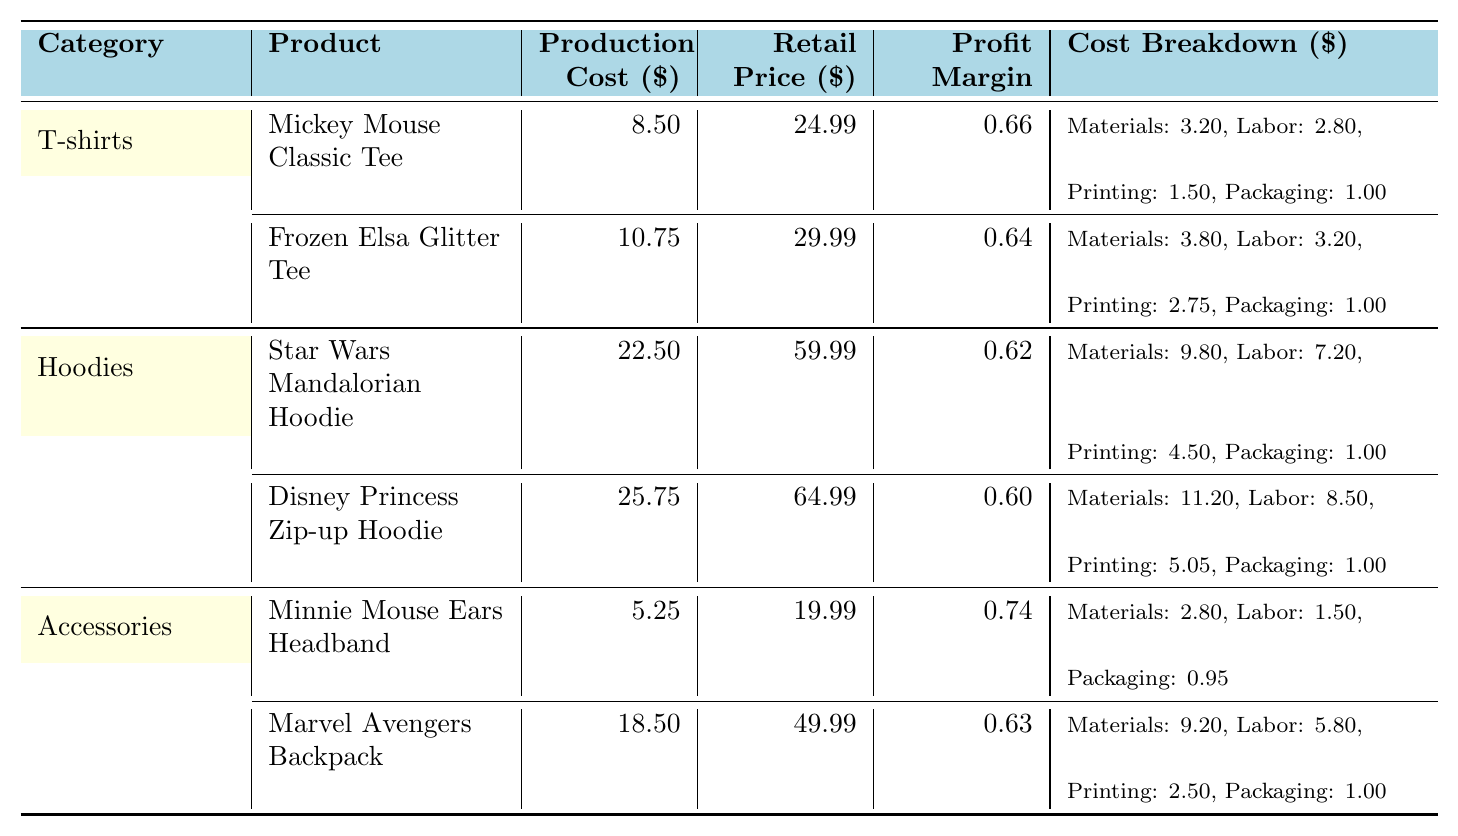What is the profit margin of the Mickey Mouse Classic Tee? The profit margin for the Mickey Mouse Classic Tee is listed in the table under the Profit Margin column, which shows a value of 0.66.
Answer: 0.66 What is the production cost of the Frozen Elsa Glitter Tee? The production cost of the Frozen Elsa Glitter Tee can be found under the Production Cost column, which indicates a value of 10.75.
Answer: 10.75 Which product has the highest profit margin? By comparing the profit margins in the Profit Margin column, the Minnie Mouse Ears Headband has a profit margin of 0.74, which is higher than the others.
Answer: Minnie Mouse Ears Headband What is the total production cost for all T-shirts? The production costs for T-shirts are 8.50 (Mickey Mouse Classic Tee) and 10.75 (Frozen Elsa Glitter Tee). The total is calculated as 8.50 + 10.75 = 19.25.
Answer: 19.25 Which category has the highest retail price for a product? By examining the Retail Price column, the Disney Princess Zip-up Hoodie has the highest retail price of 64.99.
Answer: Hoodies What is the average profit margin across all categories? The profit margins are 0.66, 0.64, 0.62, 0.60, 0.74, and 0.63. Summing these gives 3.19, and dividing by the 6 products gives an average of 3.19 / 6 = 0.5317, which rounds to 0.53.
Answer: 0.53 Is the production cost of the Marvel Avengers Backpack greater than the average production cost? The production costs are 8.50, 10.75, 22.50, 25.75, 5.25, and 18.50. The average is (8.50 + 10.75 + 22.50 + 25.75 + 5.25 + 18.50) / 6 = 15.75. The Marvel Avengers Backpack production cost is 18.50, which is greater than 15.75.
Answer: Yes What is the total cost of materials for all products? The sum of materials costs is calculated: 3.20 (T-shirts) + 3.80 (T-shirts) + 9.80 (Hoodies) + 11.20 (Hoodies) + 2.80 (Accessories) + 9.20 (Accessories) = 40.00.
Answer: 40.00 What is the difference in production costs between the most expensive and the cheapest product? The most expensive product is the Disney Princess Zip-up Hoodie at 25.75, and the cheapest is the Minnie Mouse Ears Headband at 5.25. The difference is 25.75 - 5.25 = 20.50.
Answer: 20.50 Are there any accessories with a profit margin higher than 0.70? The profit margins for accessories are 0.74 (Minnie Mouse Ears Headband) and 0.63 (Marvel Avengers Backpack). Since 0.74 is higher than 0.70, the answer is yes.
Answer: Yes 